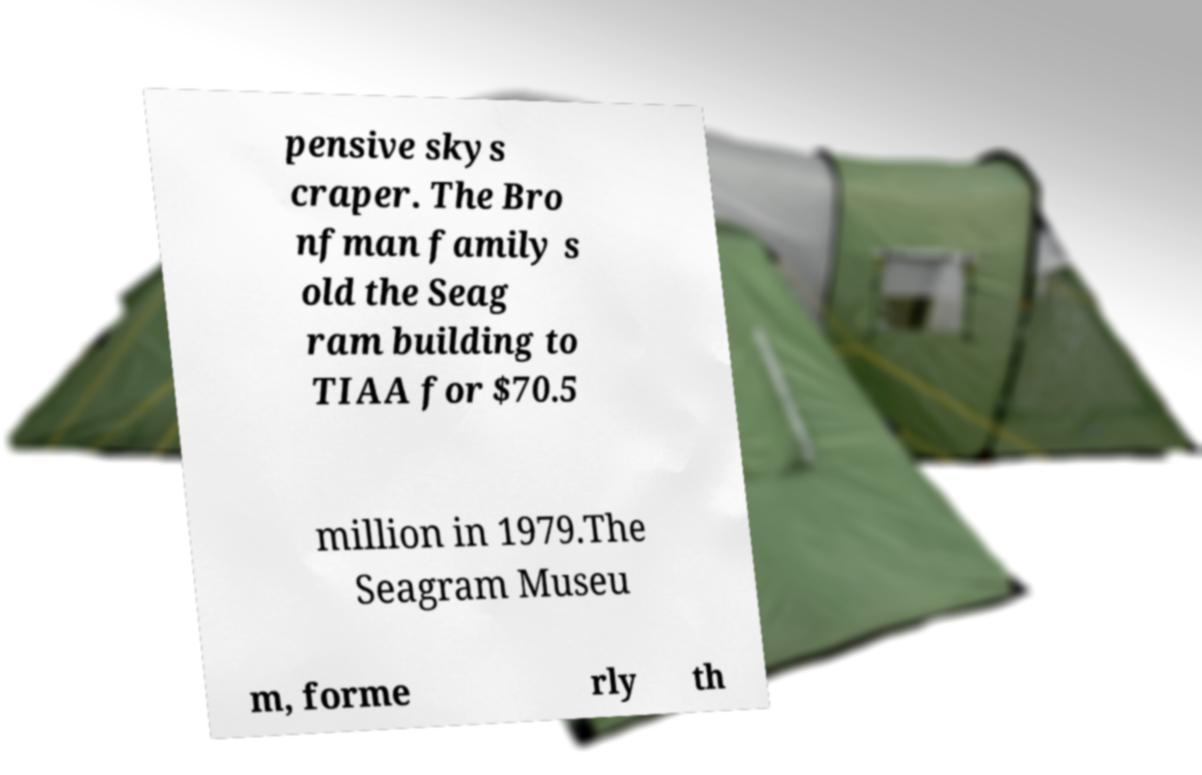Please read and relay the text visible in this image. What does it say? pensive skys craper. The Bro nfman family s old the Seag ram building to TIAA for $70.5 million in 1979.The Seagram Museu m, forme rly th 